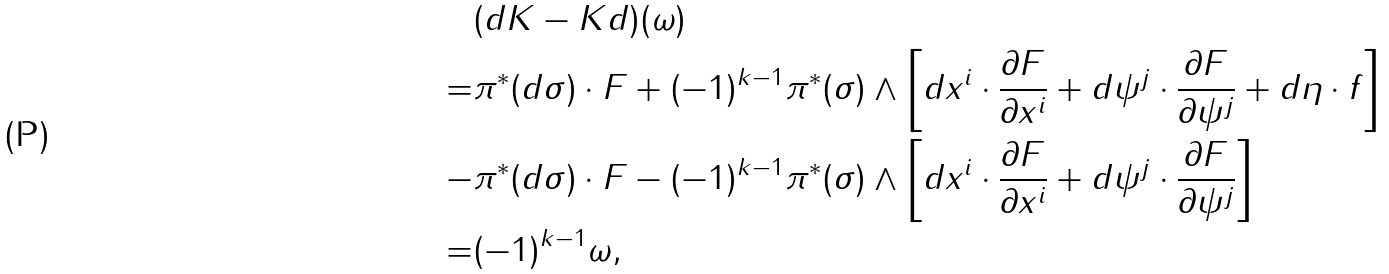<formula> <loc_0><loc_0><loc_500><loc_500>& ( d K - K d ) ( \omega ) \\ = & \pi ^ { * } ( d \sigma ) \cdot F + ( - 1 ) ^ { k - 1 } \pi ^ { * } ( \sigma ) \wedge \left [ d x ^ { i } \cdot \frac { \partial F } { \partial x ^ { i } } + d \psi ^ { j } \cdot \frac { \partial F } { \partial \psi ^ { j } } + d \eta \cdot f \right ] \\ - & \pi ^ { * } ( d \sigma ) \cdot F - ( - 1 ) ^ { k - 1 } \pi ^ { * } ( \sigma ) \wedge \left [ d x ^ { i } \cdot \frac { \partial F } { \partial x ^ { i } } + d \psi ^ { j } \cdot \frac { \partial F } { \partial \psi ^ { j } } \right ] \\ = & ( - 1 ) ^ { k - 1 } \omega ,</formula> 